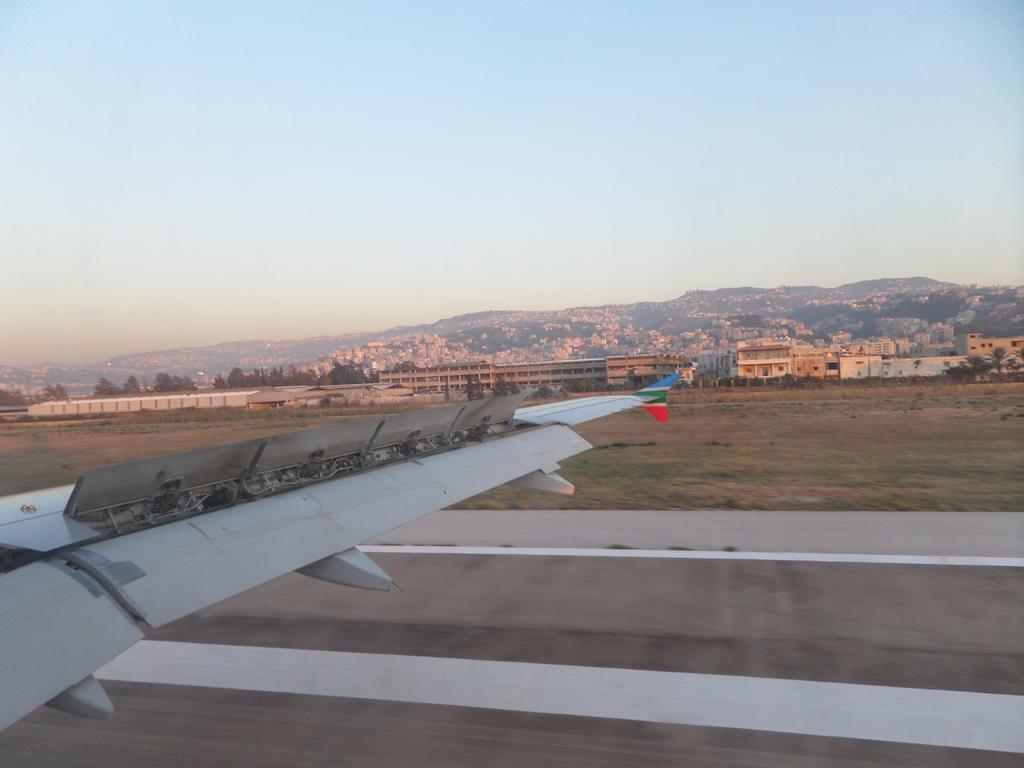How would you summarize this image in a sentence or two? In this image I can see a road. On the left side I can see a part of the aircraft. In the background, I can see the trees and the sky. 